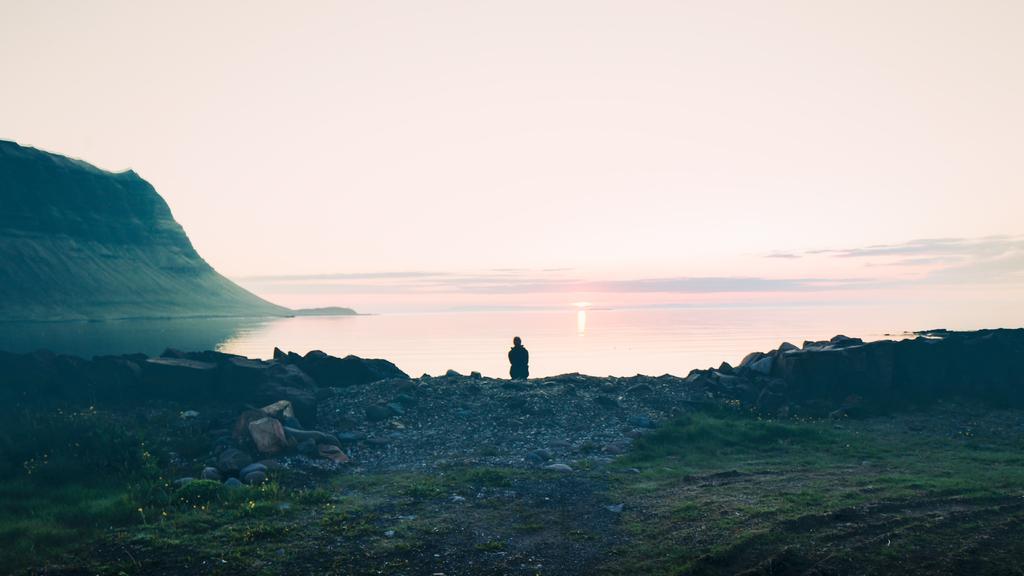In one or two sentences, can you explain what this image depicts? In this image we can see a person here, we can see grass, rocks, water, hill, the sun and the sky in the background. 